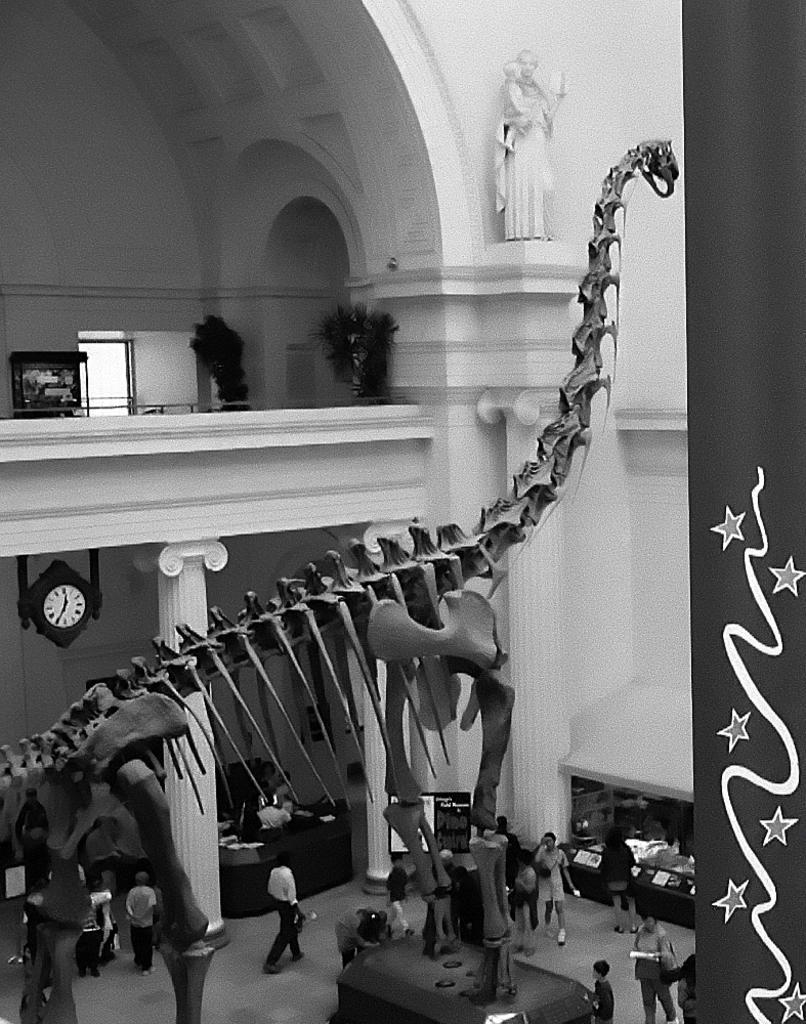Describe this image in one or two sentences. It looks like a black and white picture. We can see there is a skeleton of an animal and on the floor there are groups of people. Behind the skeleton there is a sculpture, clock, pillars, house plants, wall and other things. 